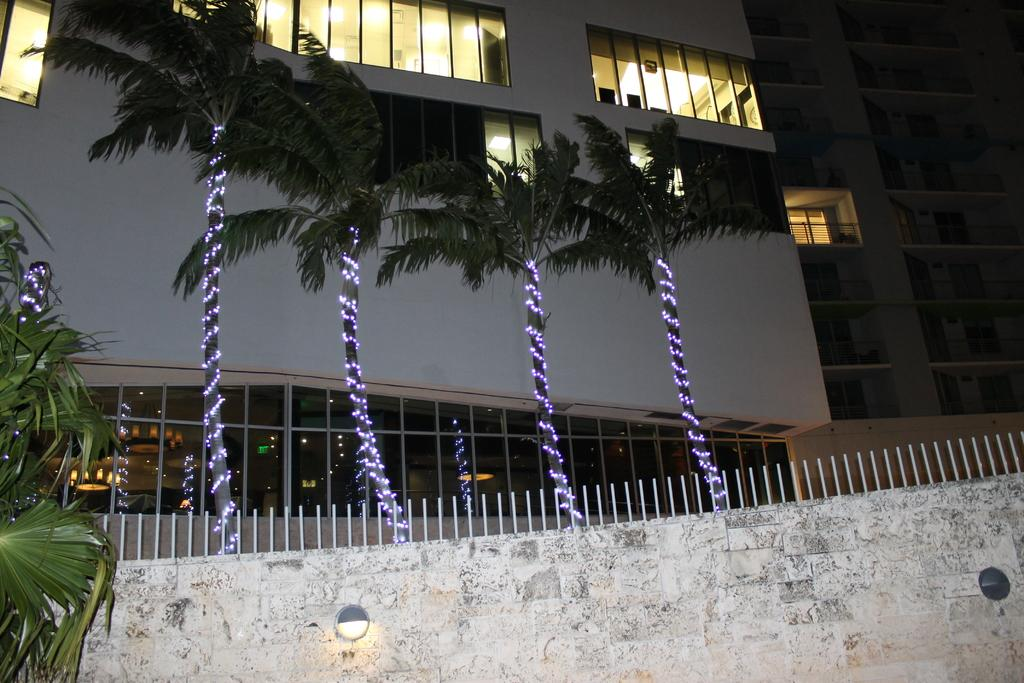What is the main structure in the image? There is a wall in the image. What is attached to the wall? Small poles are attached to the wall. What can be seen in the background of the image? There are trees and buildings visible behind the trees. What type of lighting is present near the trees? There is lighting present near the trees. How many trees are visible on the left side of the image? There is one tree on the left side of the image. What type of shirt is the tree wearing in the image? Trees do not wear shirts, so this question is not applicable to the image. 